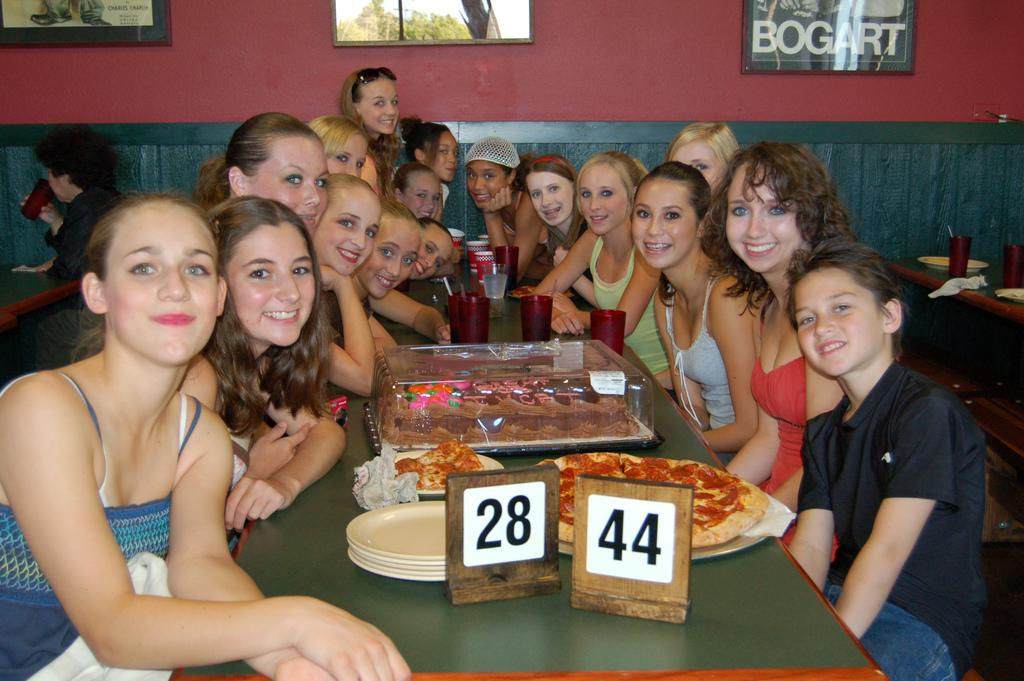What are the people in the image doing? There are persons sitting on a bench in the image. What object is present near the people? There is a table in the image. What is on the table? There is a plate on the table, and there is food on the table. What can be seen in the background of the image? There is a wall with photo frames in the background. Can you see the dog playing in the river in the image? There is no dog or river present in the image. 